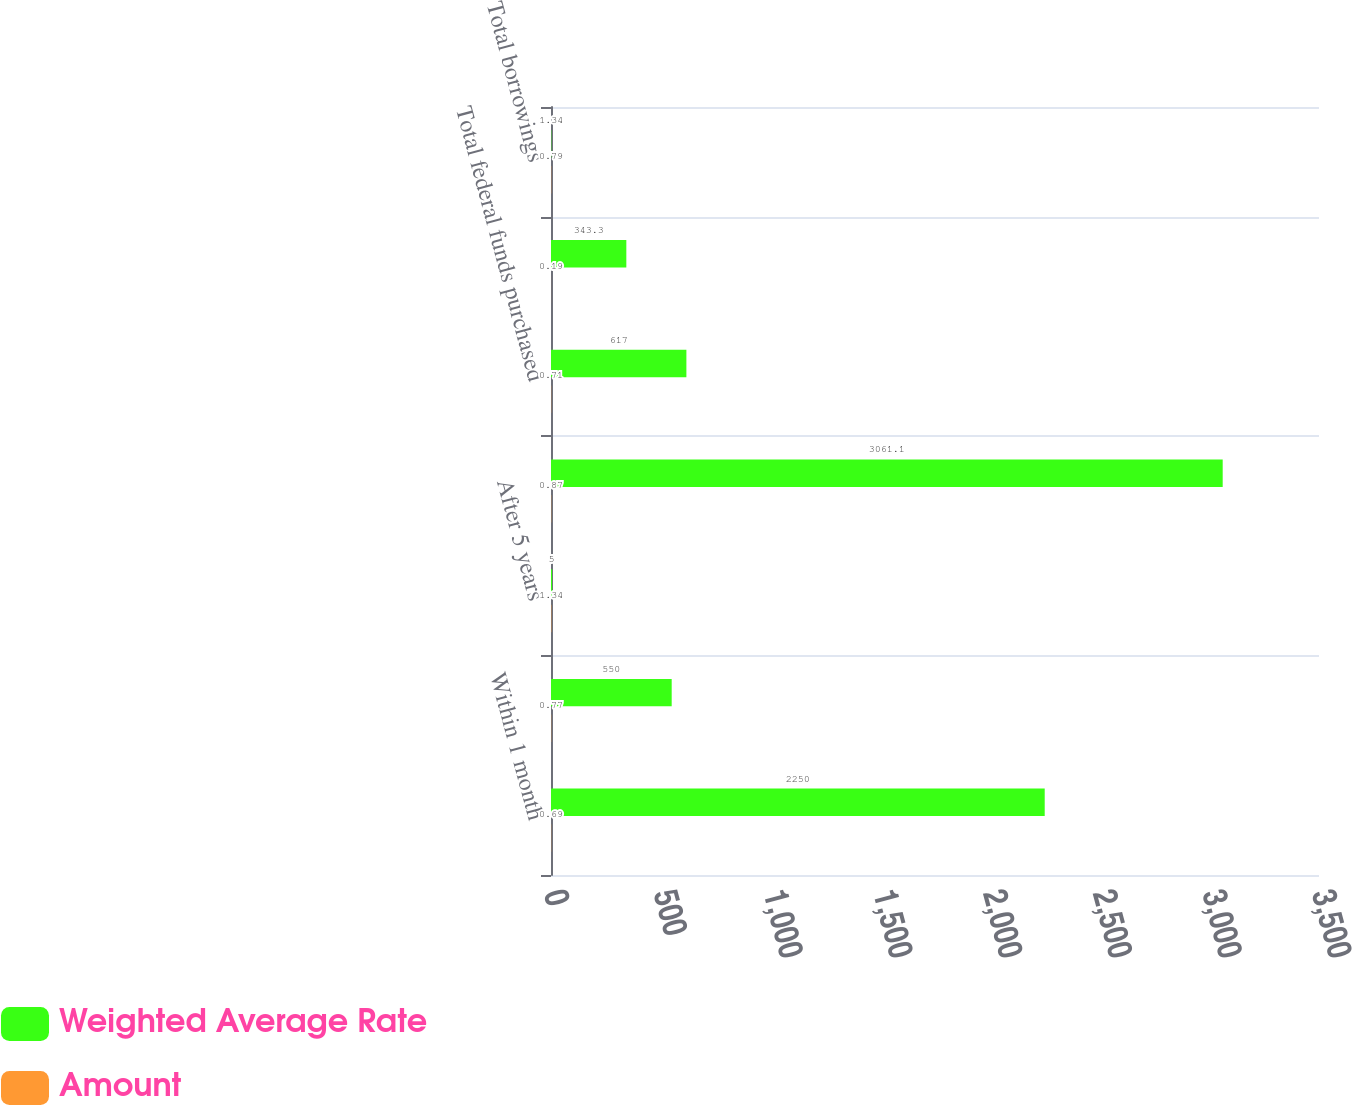<chart> <loc_0><loc_0><loc_500><loc_500><stacked_bar_chart><ecel><fcel>Within 1 month<fcel>After 1 month but within 1<fcel>After 5 years<fcel>Total FHLB advances<fcel>Total federal funds purchased<fcel>Total customer repurchase<fcel>Total borrowings<nl><fcel>Weighted Average Rate<fcel>2250<fcel>550<fcel>5<fcel>3061.1<fcel>617<fcel>343.3<fcel>1.34<nl><fcel>Amount<fcel>0.69<fcel>0.77<fcel>1.34<fcel>0.87<fcel>0.71<fcel>0.19<fcel>0.79<nl></chart> 